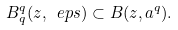Convert formula to latex. <formula><loc_0><loc_0><loc_500><loc_500>B _ { q } ^ { q } ( z , \ e p s ) \subset B ( z , a ^ { q } ) .</formula> 